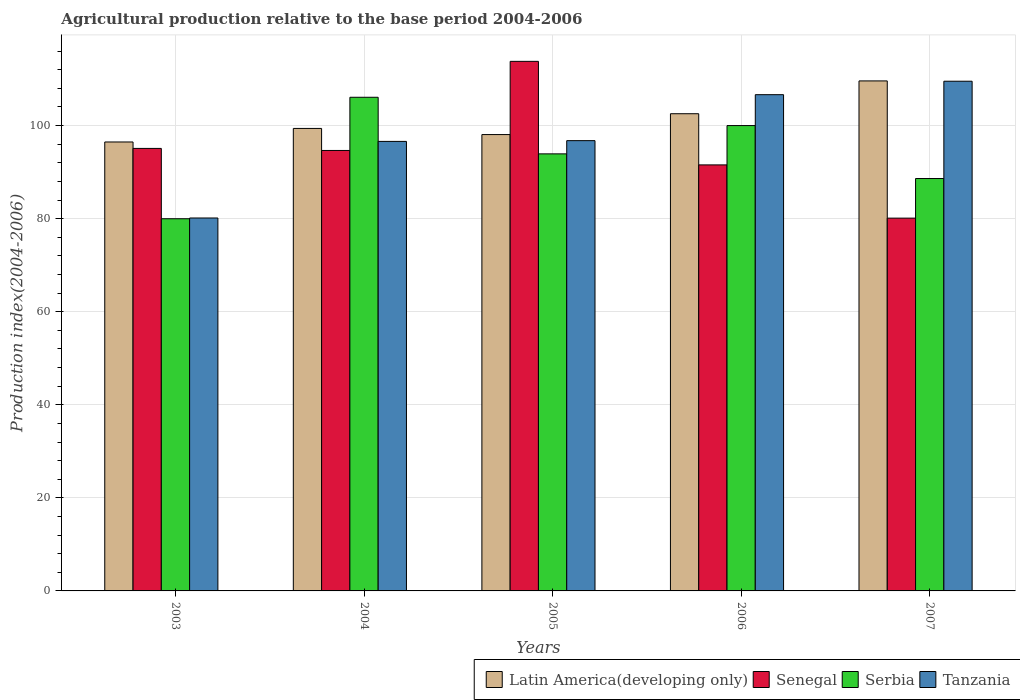How many different coloured bars are there?
Your response must be concise. 4. How many groups of bars are there?
Your response must be concise. 5. Are the number of bars on each tick of the X-axis equal?
Your answer should be very brief. Yes. How many bars are there on the 5th tick from the left?
Your answer should be very brief. 4. What is the label of the 5th group of bars from the left?
Your answer should be very brief. 2007. In how many cases, is the number of bars for a given year not equal to the number of legend labels?
Keep it short and to the point. 0. What is the agricultural production index in Latin America(developing only) in 2007?
Your response must be concise. 109.59. Across all years, what is the maximum agricultural production index in Tanzania?
Your answer should be compact. 109.53. Across all years, what is the minimum agricultural production index in Senegal?
Ensure brevity in your answer.  80.11. What is the total agricultural production index in Senegal in the graph?
Offer a terse response. 475.2. What is the difference between the agricultural production index in Tanzania in 2004 and that in 2005?
Make the answer very short. -0.16. What is the difference between the agricultural production index in Tanzania in 2003 and the agricultural production index in Senegal in 2006?
Your answer should be very brief. -11.41. What is the average agricultural production index in Serbia per year?
Offer a terse response. 93.72. In the year 2004, what is the difference between the agricultural production index in Tanzania and agricultural production index in Senegal?
Your response must be concise. 1.95. What is the ratio of the agricultural production index in Tanzania in 2005 to that in 2006?
Your response must be concise. 0.91. Is the agricultural production index in Tanzania in 2005 less than that in 2006?
Your answer should be compact. Yes. What is the difference between the highest and the second highest agricultural production index in Latin America(developing only)?
Make the answer very short. 7.05. What is the difference between the highest and the lowest agricultural production index in Tanzania?
Your answer should be compact. 29.39. In how many years, is the agricultural production index in Tanzania greater than the average agricultural production index in Tanzania taken over all years?
Your answer should be compact. 2. Is the sum of the agricultural production index in Serbia in 2003 and 2006 greater than the maximum agricultural production index in Tanzania across all years?
Offer a very short reply. Yes. Is it the case that in every year, the sum of the agricultural production index in Serbia and agricultural production index in Latin America(developing only) is greater than the sum of agricultural production index in Senegal and agricultural production index in Tanzania?
Ensure brevity in your answer.  No. What does the 2nd bar from the left in 2005 represents?
Give a very brief answer. Senegal. What does the 2nd bar from the right in 2005 represents?
Provide a succinct answer. Serbia. Is it the case that in every year, the sum of the agricultural production index in Senegal and agricultural production index in Tanzania is greater than the agricultural production index in Latin America(developing only)?
Make the answer very short. Yes. Does the graph contain any zero values?
Provide a short and direct response. No. Where does the legend appear in the graph?
Offer a very short reply. Bottom right. How are the legend labels stacked?
Offer a terse response. Horizontal. What is the title of the graph?
Give a very brief answer. Agricultural production relative to the base period 2004-2006. What is the label or title of the Y-axis?
Keep it short and to the point. Production index(2004-2006). What is the Production index(2004-2006) in Latin America(developing only) in 2003?
Offer a terse response. 96.47. What is the Production index(2004-2006) of Senegal in 2003?
Keep it short and to the point. 95.09. What is the Production index(2004-2006) in Serbia in 2003?
Ensure brevity in your answer.  79.98. What is the Production index(2004-2006) in Tanzania in 2003?
Provide a short and direct response. 80.14. What is the Production index(2004-2006) in Latin America(developing only) in 2004?
Your response must be concise. 99.39. What is the Production index(2004-2006) of Senegal in 2004?
Your response must be concise. 94.65. What is the Production index(2004-2006) of Serbia in 2004?
Offer a very short reply. 106.08. What is the Production index(2004-2006) in Tanzania in 2004?
Give a very brief answer. 96.6. What is the Production index(2004-2006) of Latin America(developing only) in 2005?
Offer a very short reply. 98.07. What is the Production index(2004-2006) in Senegal in 2005?
Give a very brief answer. 113.8. What is the Production index(2004-2006) of Serbia in 2005?
Offer a very short reply. 93.92. What is the Production index(2004-2006) of Tanzania in 2005?
Your response must be concise. 96.76. What is the Production index(2004-2006) of Latin America(developing only) in 2006?
Ensure brevity in your answer.  102.55. What is the Production index(2004-2006) in Senegal in 2006?
Your answer should be compact. 91.55. What is the Production index(2004-2006) of Serbia in 2006?
Your response must be concise. 100. What is the Production index(2004-2006) in Tanzania in 2006?
Your response must be concise. 106.64. What is the Production index(2004-2006) in Latin America(developing only) in 2007?
Keep it short and to the point. 109.59. What is the Production index(2004-2006) in Senegal in 2007?
Give a very brief answer. 80.11. What is the Production index(2004-2006) of Serbia in 2007?
Provide a succinct answer. 88.62. What is the Production index(2004-2006) in Tanzania in 2007?
Your answer should be compact. 109.53. Across all years, what is the maximum Production index(2004-2006) in Latin America(developing only)?
Offer a terse response. 109.59. Across all years, what is the maximum Production index(2004-2006) in Senegal?
Your answer should be very brief. 113.8. Across all years, what is the maximum Production index(2004-2006) of Serbia?
Ensure brevity in your answer.  106.08. Across all years, what is the maximum Production index(2004-2006) in Tanzania?
Offer a very short reply. 109.53. Across all years, what is the minimum Production index(2004-2006) in Latin America(developing only)?
Your answer should be very brief. 96.47. Across all years, what is the minimum Production index(2004-2006) of Senegal?
Give a very brief answer. 80.11. Across all years, what is the minimum Production index(2004-2006) in Serbia?
Offer a terse response. 79.98. Across all years, what is the minimum Production index(2004-2006) in Tanzania?
Provide a short and direct response. 80.14. What is the total Production index(2004-2006) of Latin America(developing only) in the graph?
Your answer should be very brief. 506.07. What is the total Production index(2004-2006) of Senegal in the graph?
Keep it short and to the point. 475.2. What is the total Production index(2004-2006) in Serbia in the graph?
Provide a succinct answer. 468.6. What is the total Production index(2004-2006) of Tanzania in the graph?
Make the answer very short. 489.67. What is the difference between the Production index(2004-2006) of Latin America(developing only) in 2003 and that in 2004?
Your response must be concise. -2.91. What is the difference between the Production index(2004-2006) of Senegal in 2003 and that in 2004?
Your response must be concise. 0.44. What is the difference between the Production index(2004-2006) of Serbia in 2003 and that in 2004?
Offer a terse response. -26.1. What is the difference between the Production index(2004-2006) in Tanzania in 2003 and that in 2004?
Offer a very short reply. -16.46. What is the difference between the Production index(2004-2006) of Latin America(developing only) in 2003 and that in 2005?
Your response must be concise. -1.59. What is the difference between the Production index(2004-2006) in Senegal in 2003 and that in 2005?
Your answer should be compact. -18.71. What is the difference between the Production index(2004-2006) of Serbia in 2003 and that in 2005?
Give a very brief answer. -13.94. What is the difference between the Production index(2004-2006) in Tanzania in 2003 and that in 2005?
Give a very brief answer. -16.62. What is the difference between the Production index(2004-2006) in Latin America(developing only) in 2003 and that in 2006?
Make the answer very short. -6.07. What is the difference between the Production index(2004-2006) of Senegal in 2003 and that in 2006?
Offer a terse response. 3.54. What is the difference between the Production index(2004-2006) of Serbia in 2003 and that in 2006?
Provide a short and direct response. -20.02. What is the difference between the Production index(2004-2006) in Tanzania in 2003 and that in 2006?
Your answer should be very brief. -26.5. What is the difference between the Production index(2004-2006) in Latin America(developing only) in 2003 and that in 2007?
Provide a short and direct response. -13.12. What is the difference between the Production index(2004-2006) in Senegal in 2003 and that in 2007?
Give a very brief answer. 14.98. What is the difference between the Production index(2004-2006) of Serbia in 2003 and that in 2007?
Make the answer very short. -8.64. What is the difference between the Production index(2004-2006) in Tanzania in 2003 and that in 2007?
Give a very brief answer. -29.39. What is the difference between the Production index(2004-2006) of Latin America(developing only) in 2004 and that in 2005?
Your answer should be compact. 1.32. What is the difference between the Production index(2004-2006) in Senegal in 2004 and that in 2005?
Provide a short and direct response. -19.15. What is the difference between the Production index(2004-2006) in Serbia in 2004 and that in 2005?
Provide a short and direct response. 12.16. What is the difference between the Production index(2004-2006) of Tanzania in 2004 and that in 2005?
Your answer should be very brief. -0.16. What is the difference between the Production index(2004-2006) of Latin America(developing only) in 2004 and that in 2006?
Offer a terse response. -3.16. What is the difference between the Production index(2004-2006) in Senegal in 2004 and that in 2006?
Make the answer very short. 3.1. What is the difference between the Production index(2004-2006) of Serbia in 2004 and that in 2006?
Make the answer very short. 6.08. What is the difference between the Production index(2004-2006) in Tanzania in 2004 and that in 2006?
Provide a short and direct response. -10.04. What is the difference between the Production index(2004-2006) of Latin America(developing only) in 2004 and that in 2007?
Your answer should be compact. -10.21. What is the difference between the Production index(2004-2006) in Senegal in 2004 and that in 2007?
Offer a very short reply. 14.54. What is the difference between the Production index(2004-2006) in Serbia in 2004 and that in 2007?
Provide a short and direct response. 17.46. What is the difference between the Production index(2004-2006) of Tanzania in 2004 and that in 2007?
Keep it short and to the point. -12.93. What is the difference between the Production index(2004-2006) in Latin America(developing only) in 2005 and that in 2006?
Your answer should be very brief. -4.48. What is the difference between the Production index(2004-2006) of Senegal in 2005 and that in 2006?
Provide a short and direct response. 22.25. What is the difference between the Production index(2004-2006) in Serbia in 2005 and that in 2006?
Offer a terse response. -6.08. What is the difference between the Production index(2004-2006) in Tanzania in 2005 and that in 2006?
Give a very brief answer. -9.88. What is the difference between the Production index(2004-2006) in Latin America(developing only) in 2005 and that in 2007?
Your response must be concise. -11.53. What is the difference between the Production index(2004-2006) in Senegal in 2005 and that in 2007?
Offer a very short reply. 33.69. What is the difference between the Production index(2004-2006) in Serbia in 2005 and that in 2007?
Make the answer very short. 5.3. What is the difference between the Production index(2004-2006) of Tanzania in 2005 and that in 2007?
Keep it short and to the point. -12.77. What is the difference between the Production index(2004-2006) in Latin America(developing only) in 2006 and that in 2007?
Provide a succinct answer. -7.05. What is the difference between the Production index(2004-2006) of Senegal in 2006 and that in 2007?
Offer a terse response. 11.44. What is the difference between the Production index(2004-2006) in Serbia in 2006 and that in 2007?
Your answer should be compact. 11.38. What is the difference between the Production index(2004-2006) of Tanzania in 2006 and that in 2007?
Give a very brief answer. -2.89. What is the difference between the Production index(2004-2006) in Latin America(developing only) in 2003 and the Production index(2004-2006) in Senegal in 2004?
Your response must be concise. 1.82. What is the difference between the Production index(2004-2006) of Latin America(developing only) in 2003 and the Production index(2004-2006) of Serbia in 2004?
Your answer should be very brief. -9.61. What is the difference between the Production index(2004-2006) in Latin America(developing only) in 2003 and the Production index(2004-2006) in Tanzania in 2004?
Make the answer very short. -0.13. What is the difference between the Production index(2004-2006) in Senegal in 2003 and the Production index(2004-2006) in Serbia in 2004?
Your answer should be compact. -10.99. What is the difference between the Production index(2004-2006) of Senegal in 2003 and the Production index(2004-2006) of Tanzania in 2004?
Provide a short and direct response. -1.51. What is the difference between the Production index(2004-2006) in Serbia in 2003 and the Production index(2004-2006) in Tanzania in 2004?
Provide a succinct answer. -16.62. What is the difference between the Production index(2004-2006) of Latin America(developing only) in 2003 and the Production index(2004-2006) of Senegal in 2005?
Provide a short and direct response. -17.33. What is the difference between the Production index(2004-2006) in Latin America(developing only) in 2003 and the Production index(2004-2006) in Serbia in 2005?
Keep it short and to the point. 2.55. What is the difference between the Production index(2004-2006) of Latin America(developing only) in 2003 and the Production index(2004-2006) of Tanzania in 2005?
Provide a short and direct response. -0.29. What is the difference between the Production index(2004-2006) in Senegal in 2003 and the Production index(2004-2006) in Serbia in 2005?
Your response must be concise. 1.17. What is the difference between the Production index(2004-2006) in Senegal in 2003 and the Production index(2004-2006) in Tanzania in 2005?
Make the answer very short. -1.67. What is the difference between the Production index(2004-2006) in Serbia in 2003 and the Production index(2004-2006) in Tanzania in 2005?
Keep it short and to the point. -16.78. What is the difference between the Production index(2004-2006) in Latin America(developing only) in 2003 and the Production index(2004-2006) in Senegal in 2006?
Ensure brevity in your answer.  4.92. What is the difference between the Production index(2004-2006) of Latin America(developing only) in 2003 and the Production index(2004-2006) of Serbia in 2006?
Provide a short and direct response. -3.53. What is the difference between the Production index(2004-2006) in Latin America(developing only) in 2003 and the Production index(2004-2006) in Tanzania in 2006?
Your answer should be very brief. -10.17. What is the difference between the Production index(2004-2006) in Senegal in 2003 and the Production index(2004-2006) in Serbia in 2006?
Provide a short and direct response. -4.91. What is the difference between the Production index(2004-2006) in Senegal in 2003 and the Production index(2004-2006) in Tanzania in 2006?
Your response must be concise. -11.55. What is the difference between the Production index(2004-2006) in Serbia in 2003 and the Production index(2004-2006) in Tanzania in 2006?
Provide a succinct answer. -26.66. What is the difference between the Production index(2004-2006) in Latin America(developing only) in 2003 and the Production index(2004-2006) in Senegal in 2007?
Keep it short and to the point. 16.36. What is the difference between the Production index(2004-2006) in Latin America(developing only) in 2003 and the Production index(2004-2006) in Serbia in 2007?
Your answer should be very brief. 7.85. What is the difference between the Production index(2004-2006) in Latin America(developing only) in 2003 and the Production index(2004-2006) in Tanzania in 2007?
Your answer should be compact. -13.06. What is the difference between the Production index(2004-2006) in Senegal in 2003 and the Production index(2004-2006) in Serbia in 2007?
Provide a short and direct response. 6.47. What is the difference between the Production index(2004-2006) in Senegal in 2003 and the Production index(2004-2006) in Tanzania in 2007?
Give a very brief answer. -14.44. What is the difference between the Production index(2004-2006) in Serbia in 2003 and the Production index(2004-2006) in Tanzania in 2007?
Provide a succinct answer. -29.55. What is the difference between the Production index(2004-2006) in Latin America(developing only) in 2004 and the Production index(2004-2006) in Senegal in 2005?
Your response must be concise. -14.41. What is the difference between the Production index(2004-2006) in Latin America(developing only) in 2004 and the Production index(2004-2006) in Serbia in 2005?
Give a very brief answer. 5.47. What is the difference between the Production index(2004-2006) of Latin America(developing only) in 2004 and the Production index(2004-2006) of Tanzania in 2005?
Offer a very short reply. 2.63. What is the difference between the Production index(2004-2006) of Senegal in 2004 and the Production index(2004-2006) of Serbia in 2005?
Keep it short and to the point. 0.73. What is the difference between the Production index(2004-2006) of Senegal in 2004 and the Production index(2004-2006) of Tanzania in 2005?
Provide a succinct answer. -2.11. What is the difference between the Production index(2004-2006) in Serbia in 2004 and the Production index(2004-2006) in Tanzania in 2005?
Offer a terse response. 9.32. What is the difference between the Production index(2004-2006) of Latin America(developing only) in 2004 and the Production index(2004-2006) of Senegal in 2006?
Make the answer very short. 7.84. What is the difference between the Production index(2004-2006) of Latin America(developing only) in 2004 and the Production index(2004-2006) of Serbia in 2006?
Provide a short and direct response. -0.61. What is the difference between the Production index(2004-2006) in Latin America(developing only) in 2004 and the Production index(2004-2006) in Tanzania in 2006?
Offer a terse response. -7.25. What is the difference between the Production index(2004-2006) of Senegal in 2004 and the Production index(2004-2006) of Serbia in 2006?
Your answer should be compact. -5.35. What is the difference between the Production index(2004-2006) of Senegal in 2004 and the Production index(2004-2006) of Tanzania in 2006?
Keep it short and to the point. -11.99. What is the difference between the Production index(2004-2006) in Serbia in 2004 and the Production index(2004-2006) in Tanzania in 2006?
Ensure brevity in your answer.  -0.56. What is the difference between the Production index(2004-2006) of Latin America(developing only) in 2004 and the Production index(2004-2006) of Senegal in 2007?
Give a very brief answer. 19.28. What is the difference between the Production index(2004-2006) in Latin America(developing only) in 2004 and the Production index(2004-2006) in Serbia in 2007?
Keep it short and to the point. 10.77. What is the difference between the Production index(2004-2006) of Latin America(developing only) in 2004 and the Production index(2004-2006) of Tanzania in 2007?
Your response must be concise. -10.14. What is the difference between the Production index(2004-2006) in Senegal in 2004 and the Production index(2004-2006) in Serbia in 2007?
Provide a short and direct response. 6.03. What is the difference between the Production index(2004-2006) in Senegal in 2004 and the Production index(2004-2006) in Tanzania in 2007?
Offer a terse response. -14.88. What is the difference between the Production index(2004-2006) in Serbia in 2004 and the Production index(2004-2006) in Tanzania in 2007?
Offer a very short reply. -3.45. What is the difference between the Production index(2004-2006) in Latin America(developing only) in 2005 and the Production index(2004-2006) in Senegal in 2006?
Keep it short and to the point. 6.52. What is the difference between the Production index(2004-2006) in Latin America(developing only) in 2005 and the Production index(2004-2006) in Serbia in 2006?
Your answer should be very brief. -1.93. What is the difference between the Production index(2004-2006) in Latin America(developing only) in 2005 and the Production index(2004-2006) in Tanzania in 2006?
Your answer should be compact. -8.57. What is the difference between the Production index(2004-2006) of Senegal in 2005 and the Production index(2004-2006) of Tanzania in 2006?
Keep it short and to the point. 7.16. What is the difference between the Production index(2004-2006) in Serbia in 2005 and the Production index(2004-2006) in Tanzania in 2006?
Provide a short and direct response. -12.72. What is the difference between the Production index(2004-2006) in Latin America(developing only) in 2005 and the Production index(2004-2006) in Senegal in 2007?
Keep it short and to the point. 17.96. What is the difference between the Production index(2004-2006) of Latin America(developing only) in 2005 and the Production index(2004-2006) of Serbia in 2007?
Give a very brief answer. 9.45. What is the difference between the Production index(2004-2006) of Latin America(developing only) in 2005 and the Production index(2004-2006) of Tanzania in 2007?
Ensure brevity in your answer.  -11.46. What is the difference between the Production index(2004-2006) in Senegal in 2005 and the Production index(2004-2006) in Serbia in 2007?
Your answer should be very brief. 25.18. What is the difference between the Production index(2004-2006) in Senegal in 2005 and the Production index(2004-2006) in Tanzania in 2007?
Make the answer very short. 4.27. What is the difference between the Production index(2004-2006) of Serbia in 2005 and the Production index(2004-2006) of Tanzania in 2007?
Offer a terse response. -15.61. What is the difference between the Production index(2004-2006) in Latin America(developing only) in 2006 and the Production index(2004-2006) in Senegal in 2007?
Your answer should be very brief. 22.44. What is the difference between the Production index(2004-2006) in Latin America(developing only) in 2006 and the Production index(2004-2006) in Serbia in 2007?
Make the answer very short. 13.93. What is the difference between the Production index(2004-2006) in Latin America(developing only) in 2006 and the Production index(2004-2006) in Tanzania in 2007?
Make the answer very short. -6.98. What is the difference between the Production index(2004-2006) in Senegal in 2006 and the Production index(2004-2006) in Serbia in 2007?
Your response must be concise. 2.93. What is the difference between the Production index(2004-2006) in Senegal in 2006 and the Production index(2004-2006) in Tanzania in 2007?
Provide a succinct answer. -17.98. What is the difference between the Production index(2004-2006) of Serbia in 2006 and the Production index(2004-2006) of Tanzania in 2007?
Ensure brevity in your answer.  -9.53. What is the average Production index(2004-2006) in Latin America(developing only) per year?
Provide a succinct answer. 101.21. What is the average Production index(2004-2006) of Senegal per year?
Your response must be concise. 95.04. What is the average Production index(2004-2006) of Serbia per year?
Make the answer very short. 93.72. What is the average Production index(2004-2006) of Tanzania per year?
Ensure brevity in your answer.  97.93. In the year 2003, what is the difference between the Production index(2004-2006) of Latin America(developing only) and Production index(2004-2006) of Senegal?
Your answer should be compact. 1.38. In the year 2003, what is the difference between the Production index(2004-2006) in Latin America(developing only) and Production index(2004-2006) in Serbia?
Make the answer very short. 16.49. In the year 2003, what is the difference between the Production index(2004-2006) in Latin America(developing only) and Production index(2004-2006) in Tanzania?
Offer a terse response. 16.33. In the year 2003, what is the difference between the Production index(2004-2006) in Senegal and Production index(2004-2006) in Serbia?
Your answer should be compact. 15.11. In the year 2003, what is the difference between the Production index(2004-2006) of Senegal and Production index(2004-2006) of Tanzania?
Offer a terse response. 14.95. In the year 2003, what is the difference between the Production index(2004-2006) in Serbia and Production index(2004-2006) in Tanzania?
Offer a terse response. -0.16. In the year 2004, what is the difference between the Production index(2004-2006) in Latin America(developing only) and Production index(2004-2006) in Senegal?
Provide a short and direct response. 4.74. In the year 2004, what is the difference between the Production index(2004-2006) of Latin America(developing only) and Production index(2004-2006) of Serbia?
Keep it short and to the point. -6.69. In the year 2004, what is the difference between the Production index(2004-2006) in Latin America(developing only) and Production index(2004-2006) in Tanzania?
Make the answer very short. 2.79. In the year 2004, what is the difference between the Production index(2004-2006) in Senegal and Production index(2004-2006) in Serbia?
Provide a short and direct response. -11.43. In the year 2004, what is the difference between the Production index(2004-2006) in Senegal and Production index(2004-2006) in Tanzania?
Your answer should be very brief. -1.95. In the year 2004, what is the difference between the Production index(2004-2006) of Serbia and Production index(2004-2006) of Tanzania?
Keep it short and to the point. 9.48. In the year 2005, what is the difference between the Production index(2004-2006) of Latin America(developing only) and Production index(2004-2006) of Senegal?
Offer a terse response. -15.73. In the year 2005, what is the difference between the Production index(2004-2006) in Latin America(developing only) and Production index(2004-2006) in Serbia?
Provide a short and direct response. 4.15. In the year 2005, what is the difference between the Production index(2004-2006) of Latin America(developing only) and Production index(2004-2006) of Tanzania?
Your answer should be very brief. 1.31. In the year 2005, what is the difference between the Production index(2004-2006) in Senegal and Production index(2004-2006) in Serbia?
Ensure brevity in your answer.  19.88. In the year 2005, what is the difference between the Production index(2004-2006) in Senegal and Production index(2004-2006) in Tanzania?
Give a very brief answer. 17.04. In the year 2005, what is the difference between the Production index(2004-2006) of Serbia and Production index(2004-2006) of Tanzania?
Provide a short and direct response. -2.84. In the year 2006, what is the difference between the Production index(2004-2006) in Latin America(developing only) and Production index(2004-2006) in Senegal?
Your answer should be very brief. 11. In the year 2006, what is the difference between the Production index(2004-2006) of Latin America(developing only) and Production index(2004-2006) of Serbia?
Your answer should be very brief. 2.55. In the year 2006, what is the difference between the Production index(2004-2006) in Latin America(developing only) and Production index(2004-2006) in Tanzania?
Your response must be concise. -4.09. In the year 2006, what is the difference between the Production index(2004-2006) of Senegal and Production index(2004-2006) of Serbia?
Make the answer very short. -8.45. In the year 2006, what is the difference between the Production index(2004-2006) in Senegal and Production index(2004-2006) in Tanzania?
Ensure brevity in your answer.  -15.09. In the year 2006, what is the difference between the Production index(2004-2006) of Serbia and Production index(2004-2006) of Tanzania?
Your response must be concise. -6.64. In the year 2007, what is the difference between the Production index(2004-2006) in Latin America(developing only) and Production index(2004-2006) in Senegal?
Keep it short and to the point. 29.48. In the year 2007, what is the difference between the Production index(2004-2006) of Latin America(developing only) and Production index(2004-2006) of Serbia?
Offer a terse response. 20.98. In the year 2007, what is the difference between the Production index(2004-2006) of Latin America(developing only) and Production index(2004-2006) of Tanzania?
Make the answer very short. 0.07. In the year 2007, what is the difference between the Production index(2004-2006) in Senegal and Production index(2004-2006) in Serbia?
Keep it short and to the point. -8.51. In the year 2007, what is the difference between the Production index(2004-2006) of Senegal and Production index(2004-2006) of Tanzania?
Provide a succinct answer. -29.42. In the year 2007, what is the difference between the Production index(2004-2006) of Serbia and Production index(2004-2006) of Tanzania?
Ensure brevity in your answer.  -20.91. What is the ratio of the Production index(2004-2006) of Latin America(developing only) in 2003 to that in 2004?
Keep it short and to the point. 0.97. What is the ratio of the Production index(2004-2006) of Serbia in 2003 to that in 2004?
Make the answer very short. 0.75. What is the ratio of the Production index(2004-2006) in Tanzania in 2003 to that in 2004?
Your answer should be very brief. 0.83. What is the ratio of the Production index(2004-2006) of Latin America(developing only) in 2003 to that in 2005?
Provide a short and direct response. 0.98. What is the ratio of the Production index(2004-2006) in Senegal in 2003 to that in 2005?
Offer a very short reply. 0.84. What is the ratio of the Production index(2004-2006) in Serbia in 2003 to that in 2005?
Your answer should be compact. 0.85. What is the ratio of the Production index(2004-2006) of Tanzania in 2003 to that in 2005?
Offer a terse response. 0.83. What is the ratio of the Production index(2004-2006) of Latin America(developing only) in 2003 to that in 2006?
Your response must be concise. 0.94. What is the ratio of the Production index(2004-2006) in Senegal in 2003 to that in 2006?
Provide a short and direct response. 1.04. What is the ratio of the Production index(2004-2006) of Serbia in 2003 to that in 2006?
Offer a very short reply. 0.8. What is the ratio of the Production index(2004-2006) in Tanzania in 2003 to that in 2006?
Your answer should be compact. 0.75. What is the ratio of the Production index(2004-2006) in Latin America(developing only) in 2003 to that in 2007?
Ensure brevity in your answer.  0.88. What is the ratio of the Production index(2004-2006) of Senegal in 2003 to that in 2007?
Make the answer very short. 1.19. What is the ratio of the Production index(2004-2006) of Serbia in 2003 to that in 2007?
Offer a terse response. 0.9. What is the ratio of the Production index(2004-2006) of Tanzania in 2003 to that in 2007?
Ensure brevity in your answer.  0.73. What is the ratio of the Production index(2004-2006) of Latin America(developing only) in 2004 to that in 2005?
Make the answer very short. 1.01. What is the ratio of the Production index(2004-2006) in Senegal in 2004 to that in 2005?
Make the answer very short. 0.83. What is the ratio of the Production index(2004-2006) in Serbia in 2004 to that in 2005?
Make the answer very short. 1.13. What is the ratio of the Production index(2004-2006) in Tanzania in 2004 to that in 2005?
Your answer should be compact. 1. What is the ratio of the Production index(2004-2006) in Latin America(developing only) in 2004 to that in 2006?
Offer a very short reply. 0.97. What is the ratio of the Production index(2004-2006) in Senegal in 2004 to that in 2006?
Give a very brief answer. 1.03. What is the ratio of the Production index(2004-2006) in Serbia in 2004 to that in 2006?
Your answer should be very brief. 1.06. What is the ratio of the Production index(2004-2006) in Tanzania in 2004 to that in 2006?
Provide a short and direct response. 0.91. What is the ratio of the Production index(2004-2006) of Latin America(developing only) in 2004 to that in 2007?
Your answer should be compact. 0.91. What is the ratio of the Production index(2004-2006) in Senegal in 2004 to that in 2007?
Ensure brevity in your answer.  1.18. What is the ratio of the Production index(2004-2006) of Serbia in 2004 to that in 2007?
Provide a short and direct response. 1.2. What is the ratio of the Production index(2004-2006) in Tanzania in 2004 to that in 2007?
Your answer should be very brief. 0.88. What is the ratio of the Production index(2004-2006) of Latin America(developing only) in 2005 to that in 2006?
Provide a succinct answer. 0.96. What is the ratio of the Production index(2004-2006) in Senegal in 2005 to that in 2006?
Provide a succinct answer. 1.24. What is the ratio of the Production index(2004-2006) of Serbia in 2005 to that in 2006?
Keep it short and to the point. 0.94. What is the ratio of the Production index(2004-2006) of Tanzania in 2005 to that in 2006?
Ensure brevity in your answer.  0.91. What is the ratio of the Production index(2004-2006) of Latin America(developing only) in 2005 to that in 2007?
Ensure brevity in your answer.  0.89. What is the ratio of the Production index(2004-2006) of Senegal in 2005 to that in 2007?
Provide a short and direct response. 1.42. What is the ratio of the Production index(2004-2006) in Serbia in 2005 to that in 2007?
Your answer should be very brief. 1.06. What is the ratio of the Production index(2004-2006) of Tanzania in 2005 to that in 2007?
Keep it short and to the point. 0.88. What is the ratio of the Production index(2004-2006) in Latin America(developing only) in 2006 to that in 2007?
Keep it short and to the point. 0.94. What is the ratio of the Production index(2004-2006) in Senegal in 2006 to that in 2007?
Give a very brief answer. 1.14. What is the ratio of the Production index(2004-2006) in Serbia in 2006 to that in 2007?
Make the answer very short. 1.13. What is the ratio of the Production index(2004-2006) in Tanzania in 2006 to that in 2007?
Offer a terse response. 0.97. What is the difference between the highest and the second highest Production index(2004-2006) of Latin America(developing only)?
Keep it short and to the point. 7.05. What is the difference between the highest and the second highest Production index(2004-2006) in Senegal?
Ensure brevity in your answer.  18.71. What is the difference between the highest and the second highest Production index(2004-2006) in Serbia?
Provide a short and direct response. 6.08. What is the difference between the highest and the second highest Production index(2004-2006) in Tanzania?
Your answer should be compact. 2.89. What is the difference between the highest and the lowest Production index(2004-2006) in Latin America(developing only)?
Your answer should be very brief. 13.12. What is the difference between the highest and the lowest Production index(2004-2006) of Senegal?
Your answer should be very brief. 33.69. What is the difference between the highest and the lowest Production index(2004-2006) of Serbia?
Offer a very short reply. 26.1. What is the difference between the highest and the lowest Production index(2004-2006) in Tanzania?
Your answer should be very brief. 29.39. 